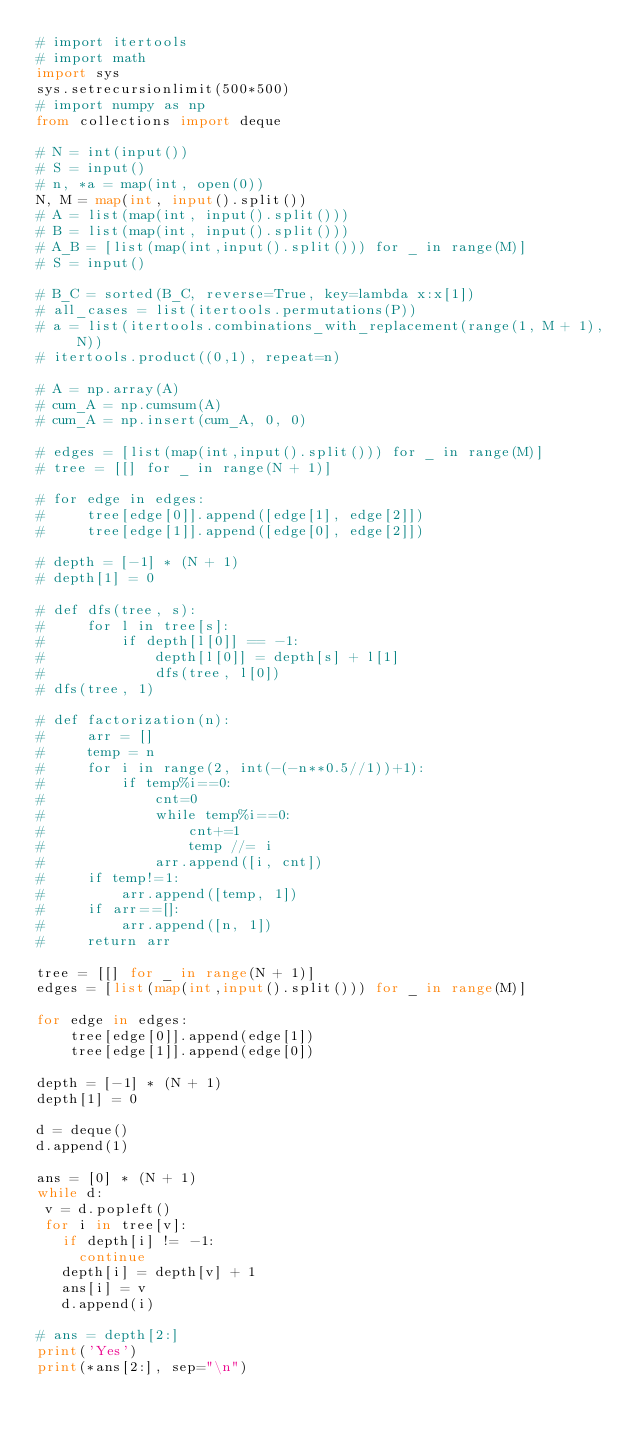Convert code to text. <code><loc_0><loc_0><loc_500><loc_500><_Python_># import itertools
# import math
import sys
sys.setrecursionlimit(500*500)
# import numpy as np
from collections import deque

# N = int(input())
# S = input()
# n, *a = map(int, open(0))
N, M = map(int, input().split())
# A = list(map(int, input().split()))
# B = list(map(int, input().split()))
# A_B = [list(map(int,input().split())) for _ in range(M)]
# S = input()

# B_C = sorted(B_C, reverse=True, key=lambda x:x[1])
# all_cases = list(itertools.permutations(P))
# a = list(itertools.combinations_with_replacement(range(1, M + 1), N))
# itertools.product((0,1), repeat=n)

# A = np.array(A)
# cum_A = np.cumsum(A)
# cum_A = np.insert(cum_A, 0, 0)

# edges = [list(map(int,input().split())) for _ in range(M)]
# tree = [[] for _ in range(N + 1)]

# for edge in edges:
#     tree[edge[0]].append([edge[1], edge[2]])
#     tree[edge[1]].append([edge[0], edge[2]])

# depth = [-1] * (N + 1)
# depth[1] = 0

# def dfs(tree, s):
#     for l in tree[s]:
#         if depth[l[0]] == -1:
#             depth[l[0]] = depth[s] + l[1]
#             dfs(tree, l[0])
# dfs(tree, 1)

# def factorization(n):
#     arr = []
#     temp = n
#     for i in range(2, int(-(-n**0.5//1))+1):
#         if temp%i==0:
#             cnt=0
#             while temp%i==0:
#                 cnt+=1
#                 temp //= i
#             arr.append([i, cnt])
#     if temp!=1:
#         arr.append([temp, 1])
#     if arr==[]:
#         arr.append([n, 1])
#     return arr

tree = [[] for _ in range(N + 1)]
edges = [list(map(int,input().split())) for _ in range(M)]

for edge in edges:
    tree[edge[0]].append(edge[1])
    tree[edge[1]].append(edge[0])

depth = [-1] * (N + 1)
depth[1] = 0

d = deque()
d.append(1)

ans = [0] * (N + 1)
while d:
 v = d.popleft()
 for i in tree[v]:
   if depth[i] != -1:
     continue
   depth[i] = depth[v] + 1
   ans[i] = v
   d.append(i)

# ans = depth[2:]
print('Yes')
print(*ans[2:], sep="\n")</code> 